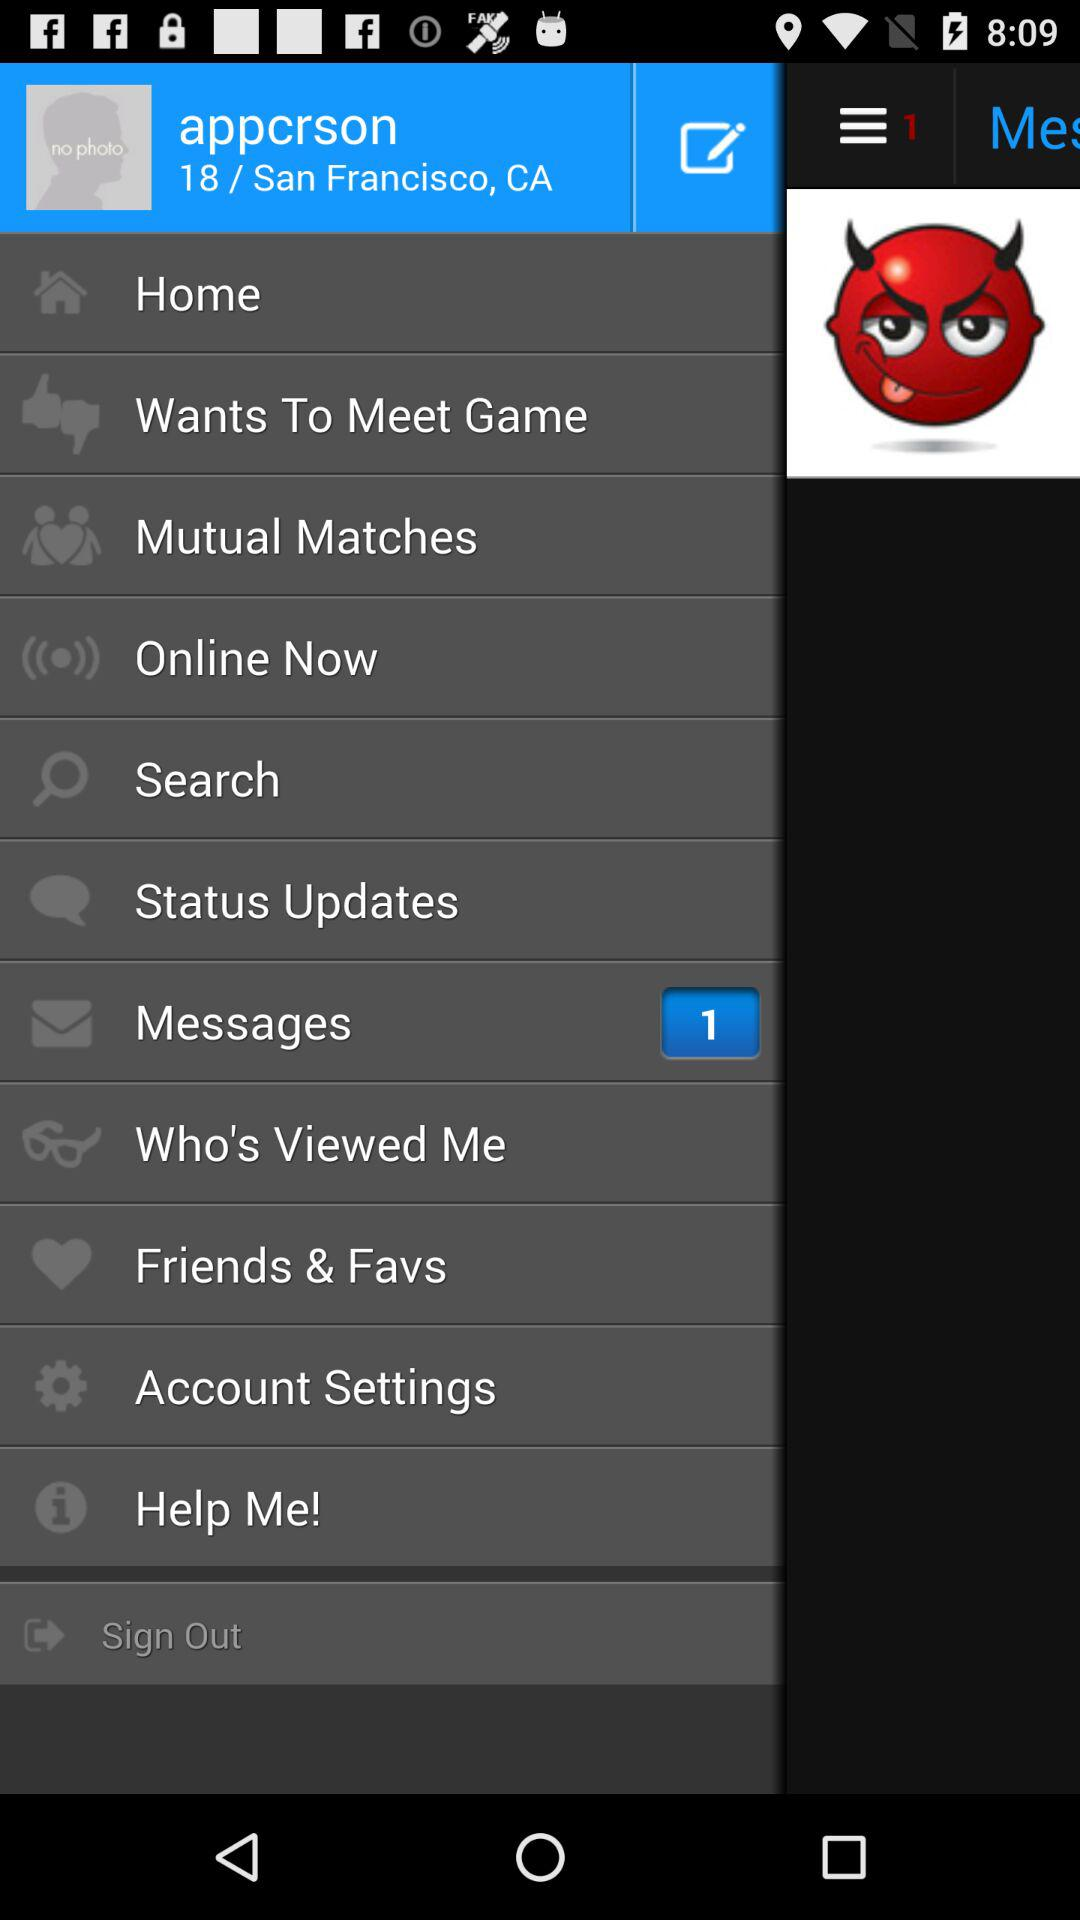What is the location of the user? The location of the user is San Francisco, CA. 